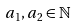Convert formula to latex. <formula><loc_0><loc_0><loc_500><loc_500>a _ { 1 } , a _ { 2 } \in \mathbb { N }</formula> 